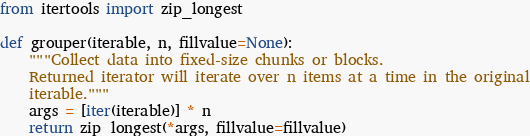Convert code to text. <code><loc_0><loc_0><loc_500><loc_500><_Python_>from itertools import zip_longest

def grouper(iterable, n, fillvalue=None):
    """Collect data into fixed-size chunks or blocks.
    Returned iterator will iterate over n items at a time in the original
    iterable."""
    args = [iter(iterable)] * n
    return zip_longest(*args, fillvalue=fillvalue)</code> 